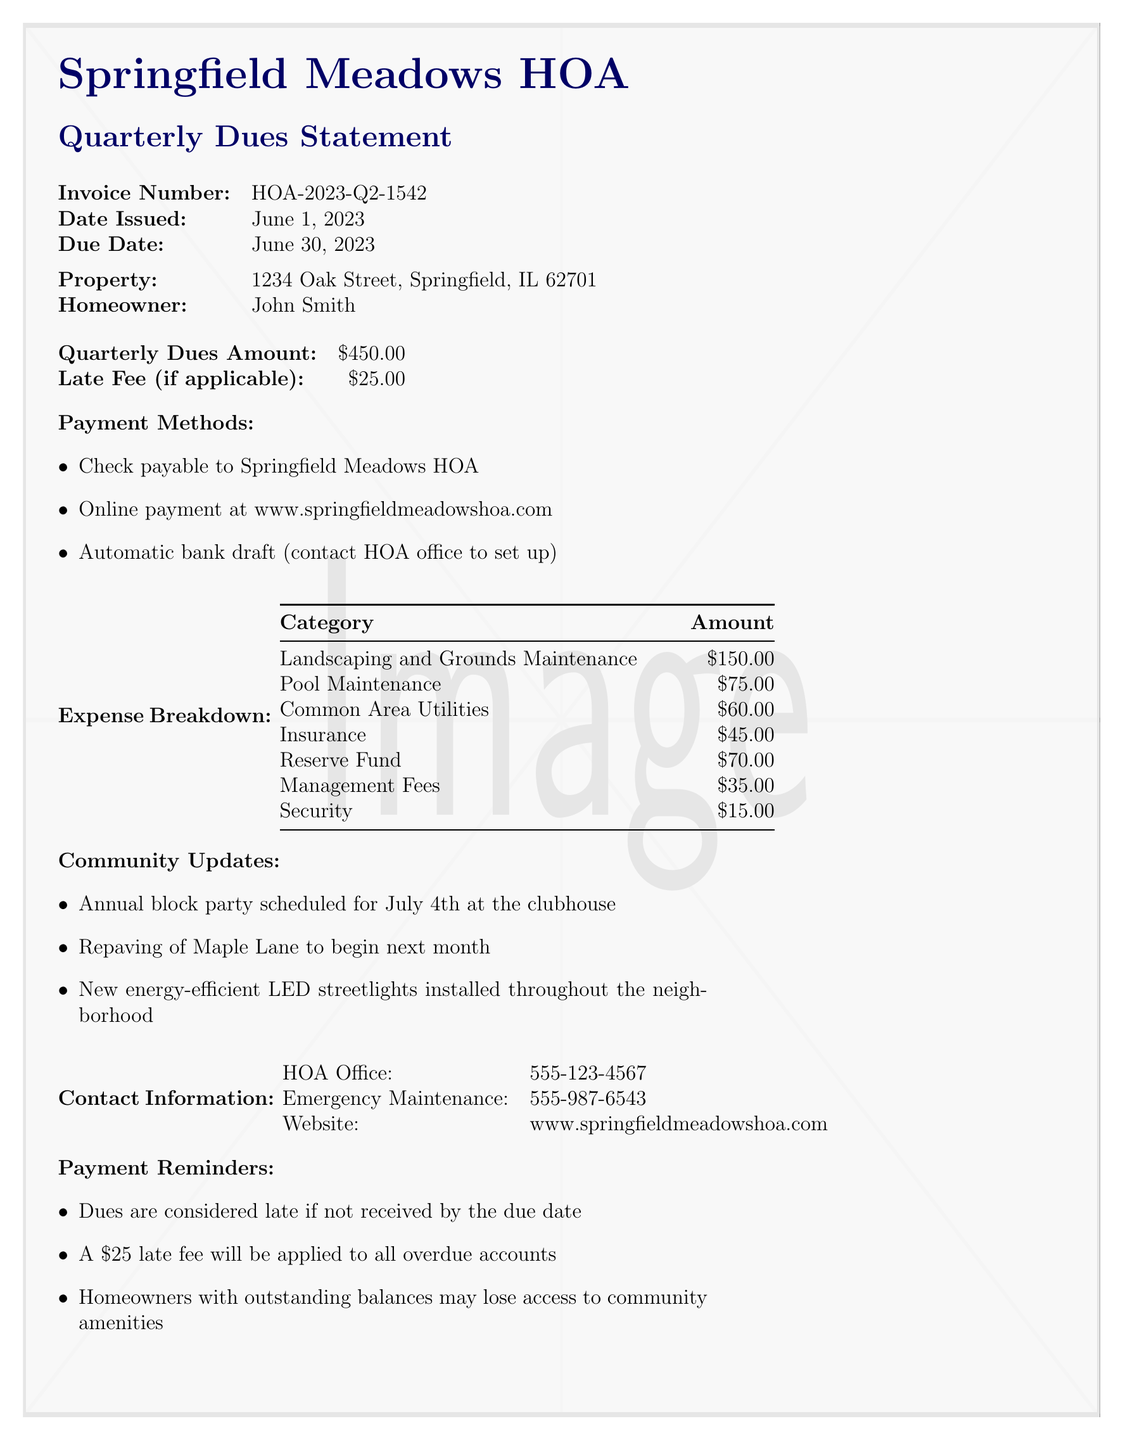what is the invoice number? The invoice number is provided in the document for reference, which is HOA-2023-Q2-1542.
Answer: HOA-2023-Q2-1542 when was the due date? The due date is specified for payment in the document, which is June 30, 2023.
Answer: June 30, 2023 what is the amount of the quarterly dues? The document states the quarterly dues amount that is required from the homeowner, which is $450.00.
Answer: $450.00 how much is the late fee? The document indicates the charge that would apply if the payment is late, which is $25.00.
Answer: $25.00 what is the total amount for Landscaping and Grounds Maintenance? The document includes a breakdown of community expenses, stating that $150.00 is allocated for landscaping and grounds maintenance.
Answer: $150.00 how many categories are listed in the expense breakdown? The document lists several categories for the expenses, allowing us to count the distinct entries, totaling 7 categories.
Answer: 7 what are the three payment methods mentioned? The document specifies three ways to make payments, which are Check, Online payment, and Automatic bank draft.
Answer: Check, Online payment, Automatic bank draft when is the annual block party scheduled? The document provides an update about the community event, stating the block party is scheduled for July 4th.
Answer: July 4th what could happen if dues are not paid on time? The document warns that homeowners with overdue accounts may face consequences regarding community access; specifically, they may lose access to amenities.
Answer: Lose access to community amenities 